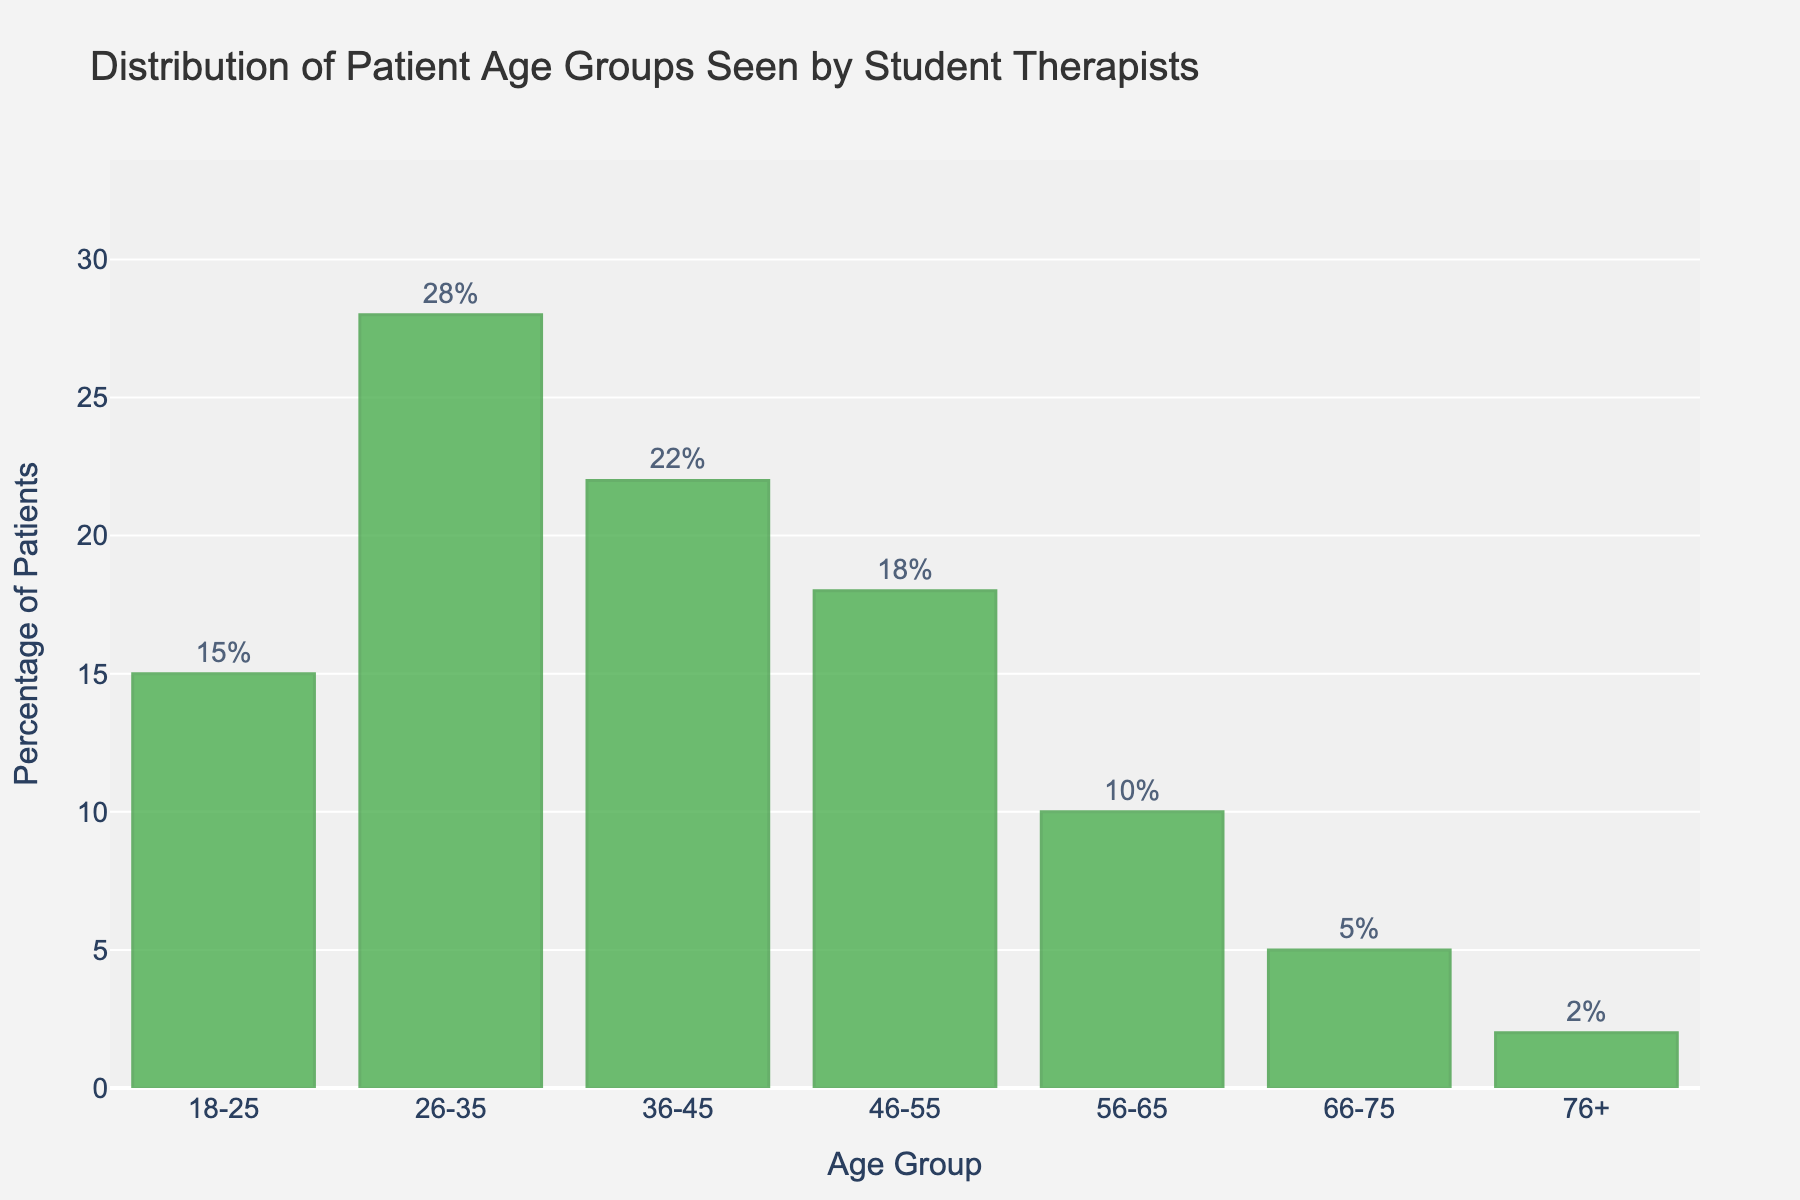What percentage of patients fall in the age group 26-35? Find the bar labeled '26-35' and read the percentage from the top of the bar. The percentage is labeled as '28'.
Answer: 28% What is the combined percentage of patients aged between 36 and 55? Add the percentages for the age groups 36-45 and 46-55. From the figure: 22 (36-45) + 18 (46-55) = 40.
Answer: 40 Which age group has the smallest percentage of patients? Identify the shortest bar in the chart and read its corresponding age group and percentage. The '76+' age group has the smallest percentage at 2%.
Answer: 76+ What is the difference in percentage of patients between the age groups 18-25 and 56-65? Subtract the percentage of the '56-65' age group from the percentage of the '18-25' age group. From the figure: 15 (18-25) - 10 (56-65) = 5.
Answer: 5 What percentage of patients are older than 55? Combine the percentages for age groups 56-65, 66-75, and 76+. From the figure: 10 (56-65) + 5 (66-75) + 2 (76+) = 17.
Answer: 17 Which age group is the second most frequent among patients? Identify the second tallest bar in the chart and read its corresponding age group. The '36-45' age group, with a percentage of 22, is the second tallest.
Answer: 36-45 How much taller is the bar for the 26-35 age group compared to the 66-75 age group? Subtract the percentage of the '66-75' age group from the percentage of the '26-35' age group. From the figure: 28 (26-35) - 5 (66-75) = 23.
Answer: 23 